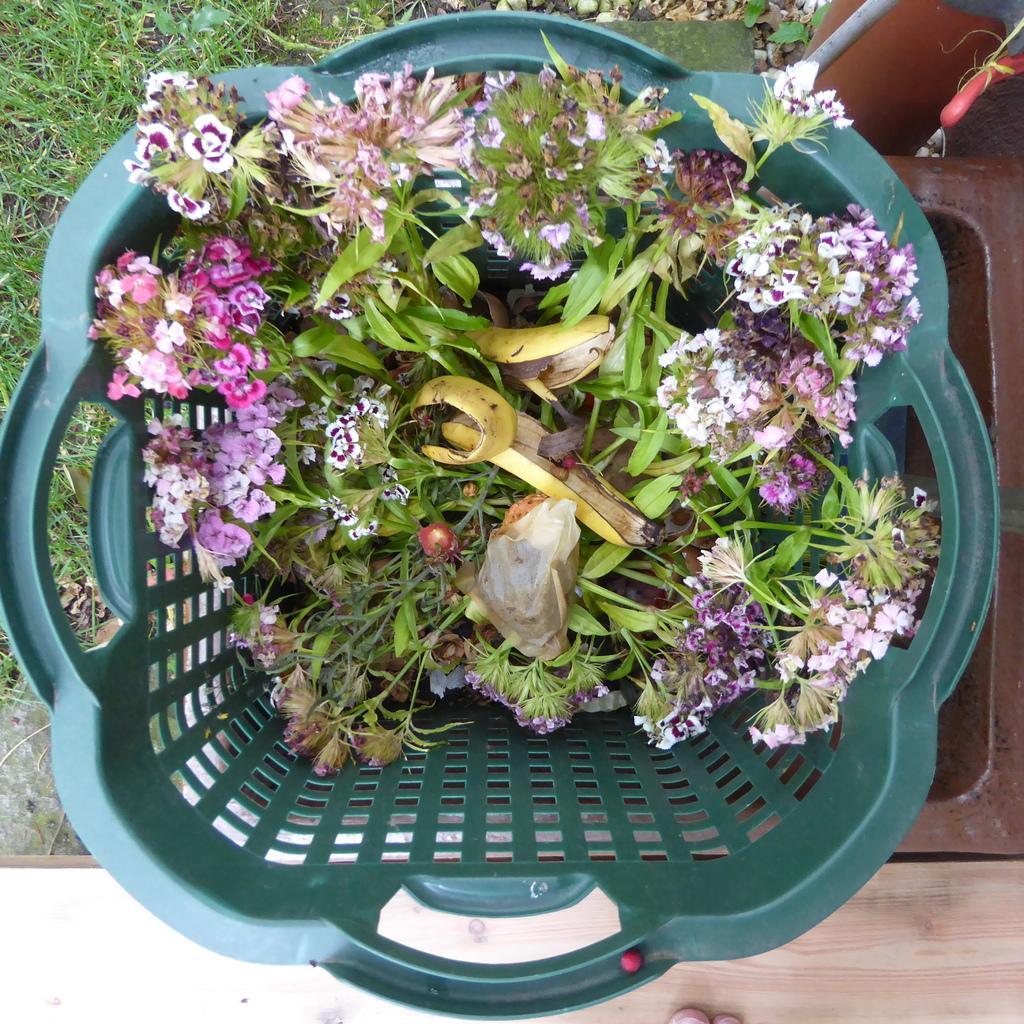Can you describe this image briefly? In this image I can see a dustbin which is placed on the ground. On the ground, I can see the grass. In the dustbin there are few flowers, leaves, a cover and banana peel. At the bottom there is wooden plank on which I can see a person's foot. On the right side there is an object which seems to be a box. 